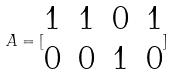Convert formula to latex. <formula><loc_0><loc_0><loc_500><loc_500>A = [ \begin{matrix} 1 & 1 & 0 & 1 \\ 0 & 0 & 1 & 0 \end{matrix} ]</formula> 